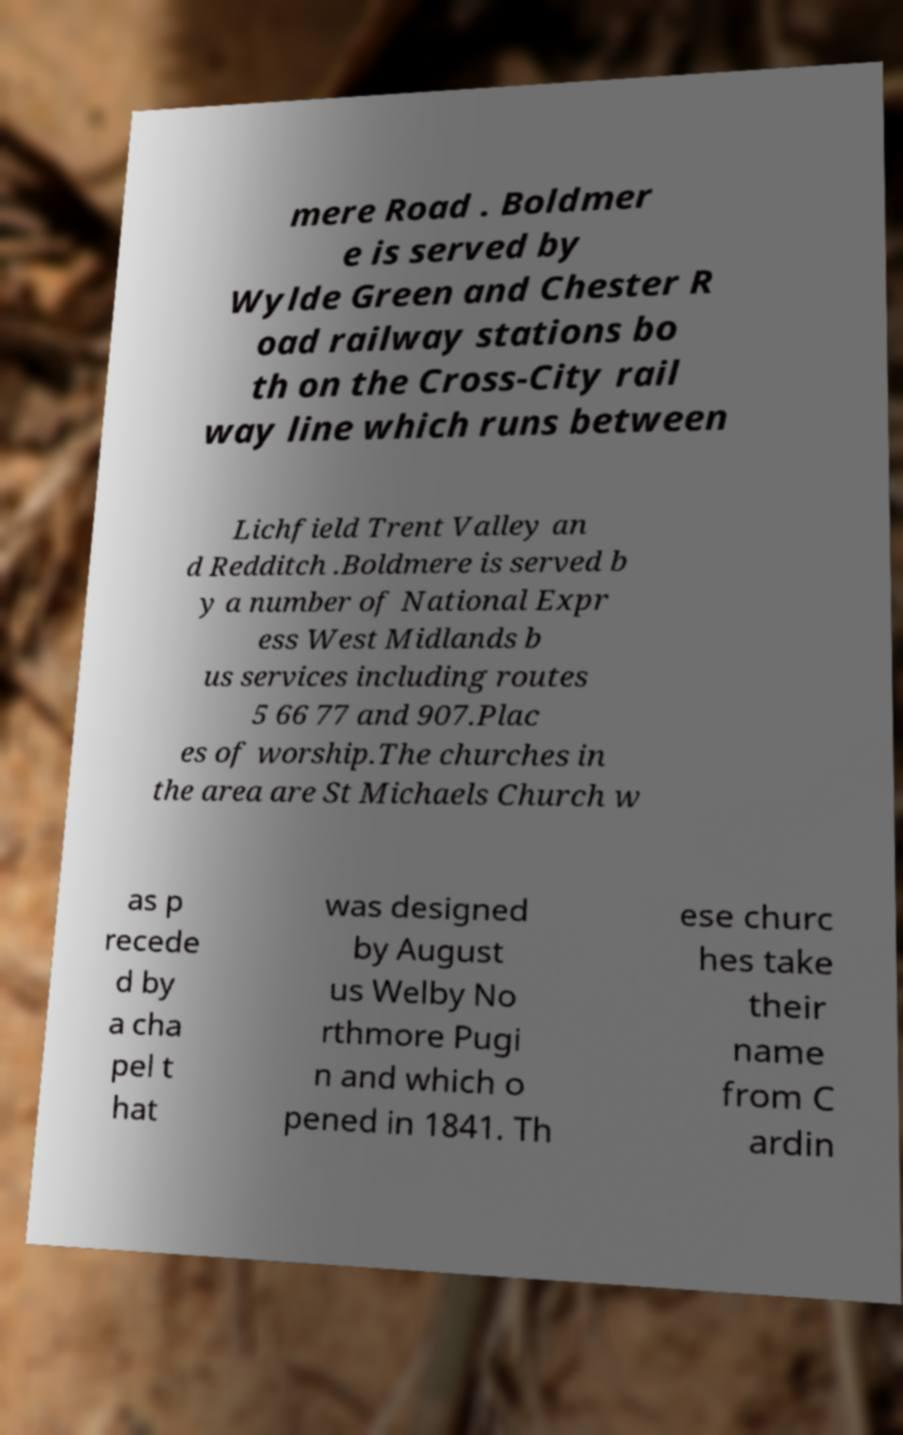Please identify and transcribe the text found in this image. mere Road . Boldmer e is served by Wylde Green and Chester R oad railway stations bo th on the Cross-City rail way line which runs between Lichfield Trent Valley an d Redditch .Boldmere is served b y a number of National Expr ess West Midlands b us services including routes 5 66 77 and 907.Plac es of worship.The churches in the area are St Michaels Church w as p recede d by a cha pel t hat was designed by August us Welby No rthmore Pugi n and which o pened in 1841. Th ese churc hes take their name from C ardin 